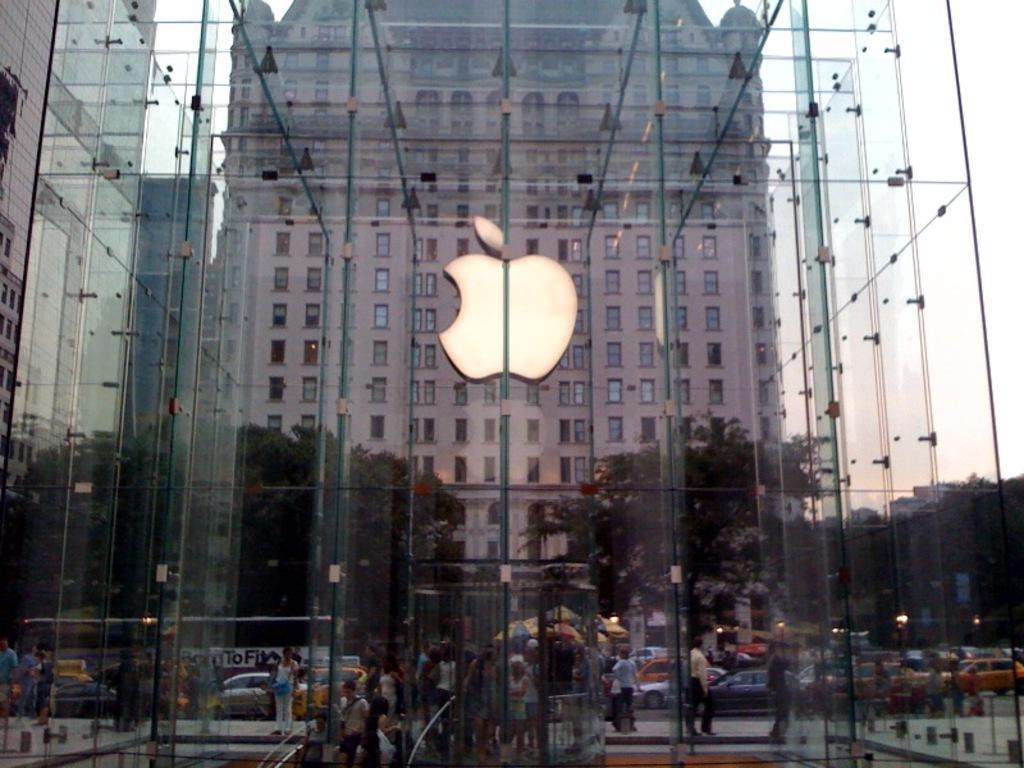How would you summarize this image in a sentence or two? In this image in the center there is a glass building, and in the background there are buildings, trees, and some persons, vehicles, tents, lights, poles and some other objects. 